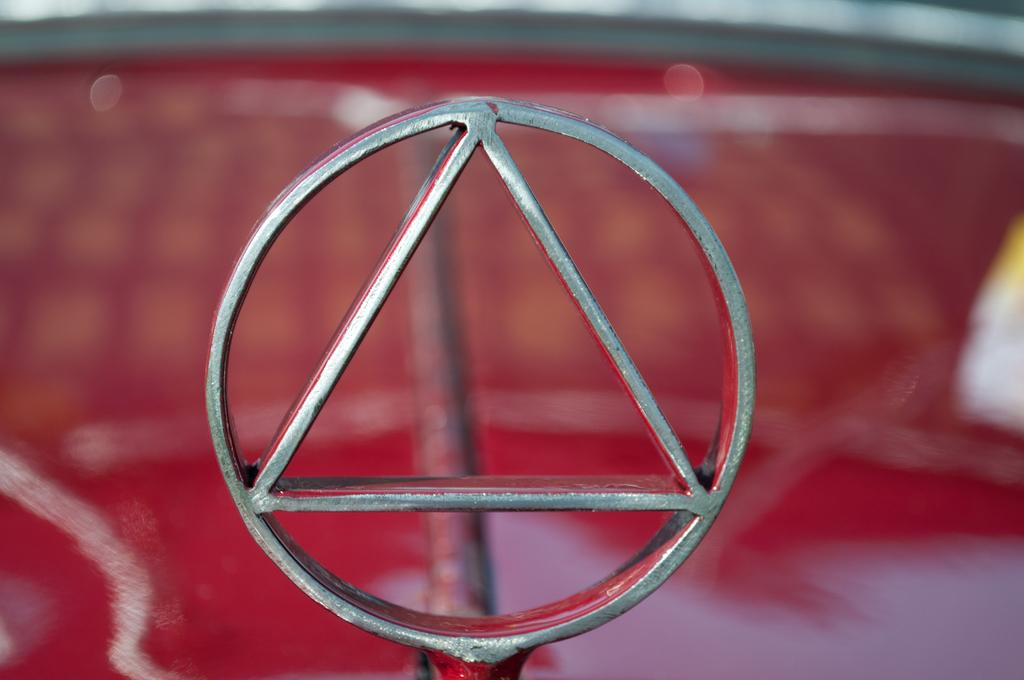What is the main feature of the image? There is a logo in the image. What else can be seen in the image besides the logo? There is a rod in the image. Can you describe the background of the image? The background of the image is blurry. How many ants can be seen crawling on the sticks in the image? There are no ants or sticks present in the image. 